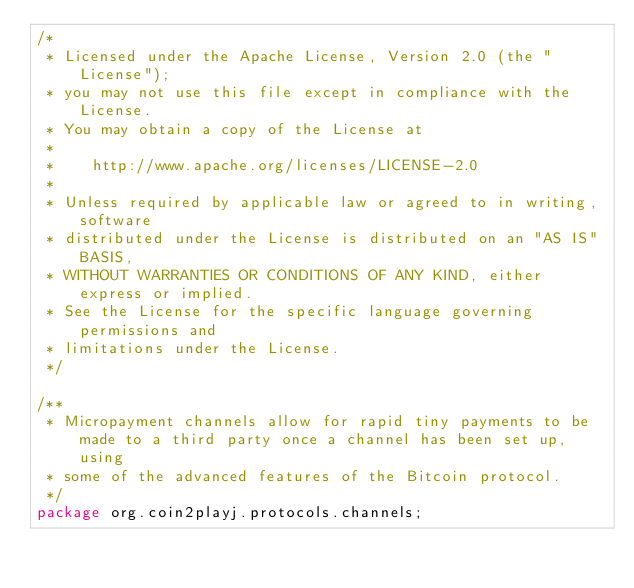Convert code to text. <code><loc_0><loc_0><loc_500><loc_500><_Java_>/*
 * Licensed under the Apache License, Version 2.0 (the "License");
 * you may not use this file except in compliance with the License.
 * You may obtain a copy of the License at
 *
 *    http://www.apache.org/licenses/LICENSE-2.0
 *
 * Unless required by applicable law or agreed to in writing, software
 * distributed under the License is distributed on an "AS IS" BASIS,
 * WITHOUT WARRANTIES OR CONDITIONS OF ANY KIND, either express or implied.
 * See the License for the specific language governing permissions and
 * limitations under the License.
 */

/**
 * Micropayment channels allow for rapid tiny payments to be made to a third party once a channel has been set up, using
 * some of the advanced features of the Bitcoin protocol.
 */
package org.coin2playj.protocols.channels;</code> 